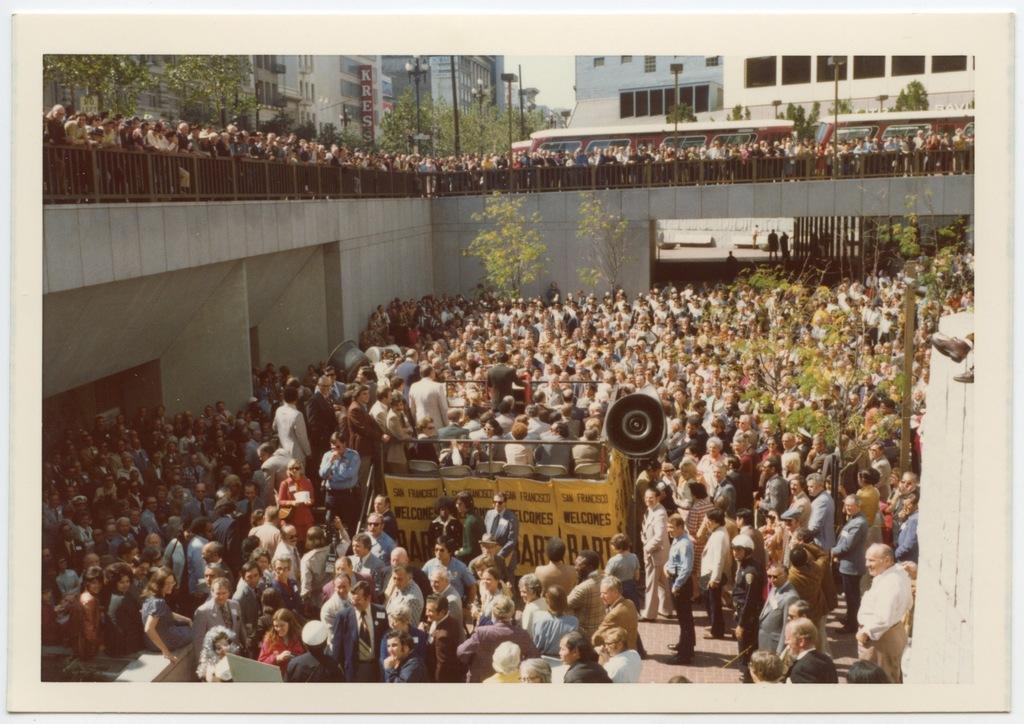Could you give a brief overview of what you see in this image? In this image I can see many people. At the top I can see some people standing near the rail. In the background, I can see the buildings with some text written on it. 